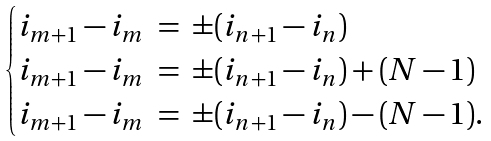Convert formula to latex. <formula><loc_0><loc_0><loc_500><loc_500>\begin{cases} i _ { m + 1 } - i _ { m } \ = \ \pm ( i _ { n + 1 } - i _ { n } ) \\ i _ { m + 1 } - i _ { m } \ = \ \pm ( i _ { n + 1 } - i _ { n } ) + ( N - 1 ) \\ i _ { m + 1 } - i _ { m } \ = \ \pm ( i _ { n + 1 } - i _ { n } ) - ( N - 1 ) . \end{cases}</formula> 